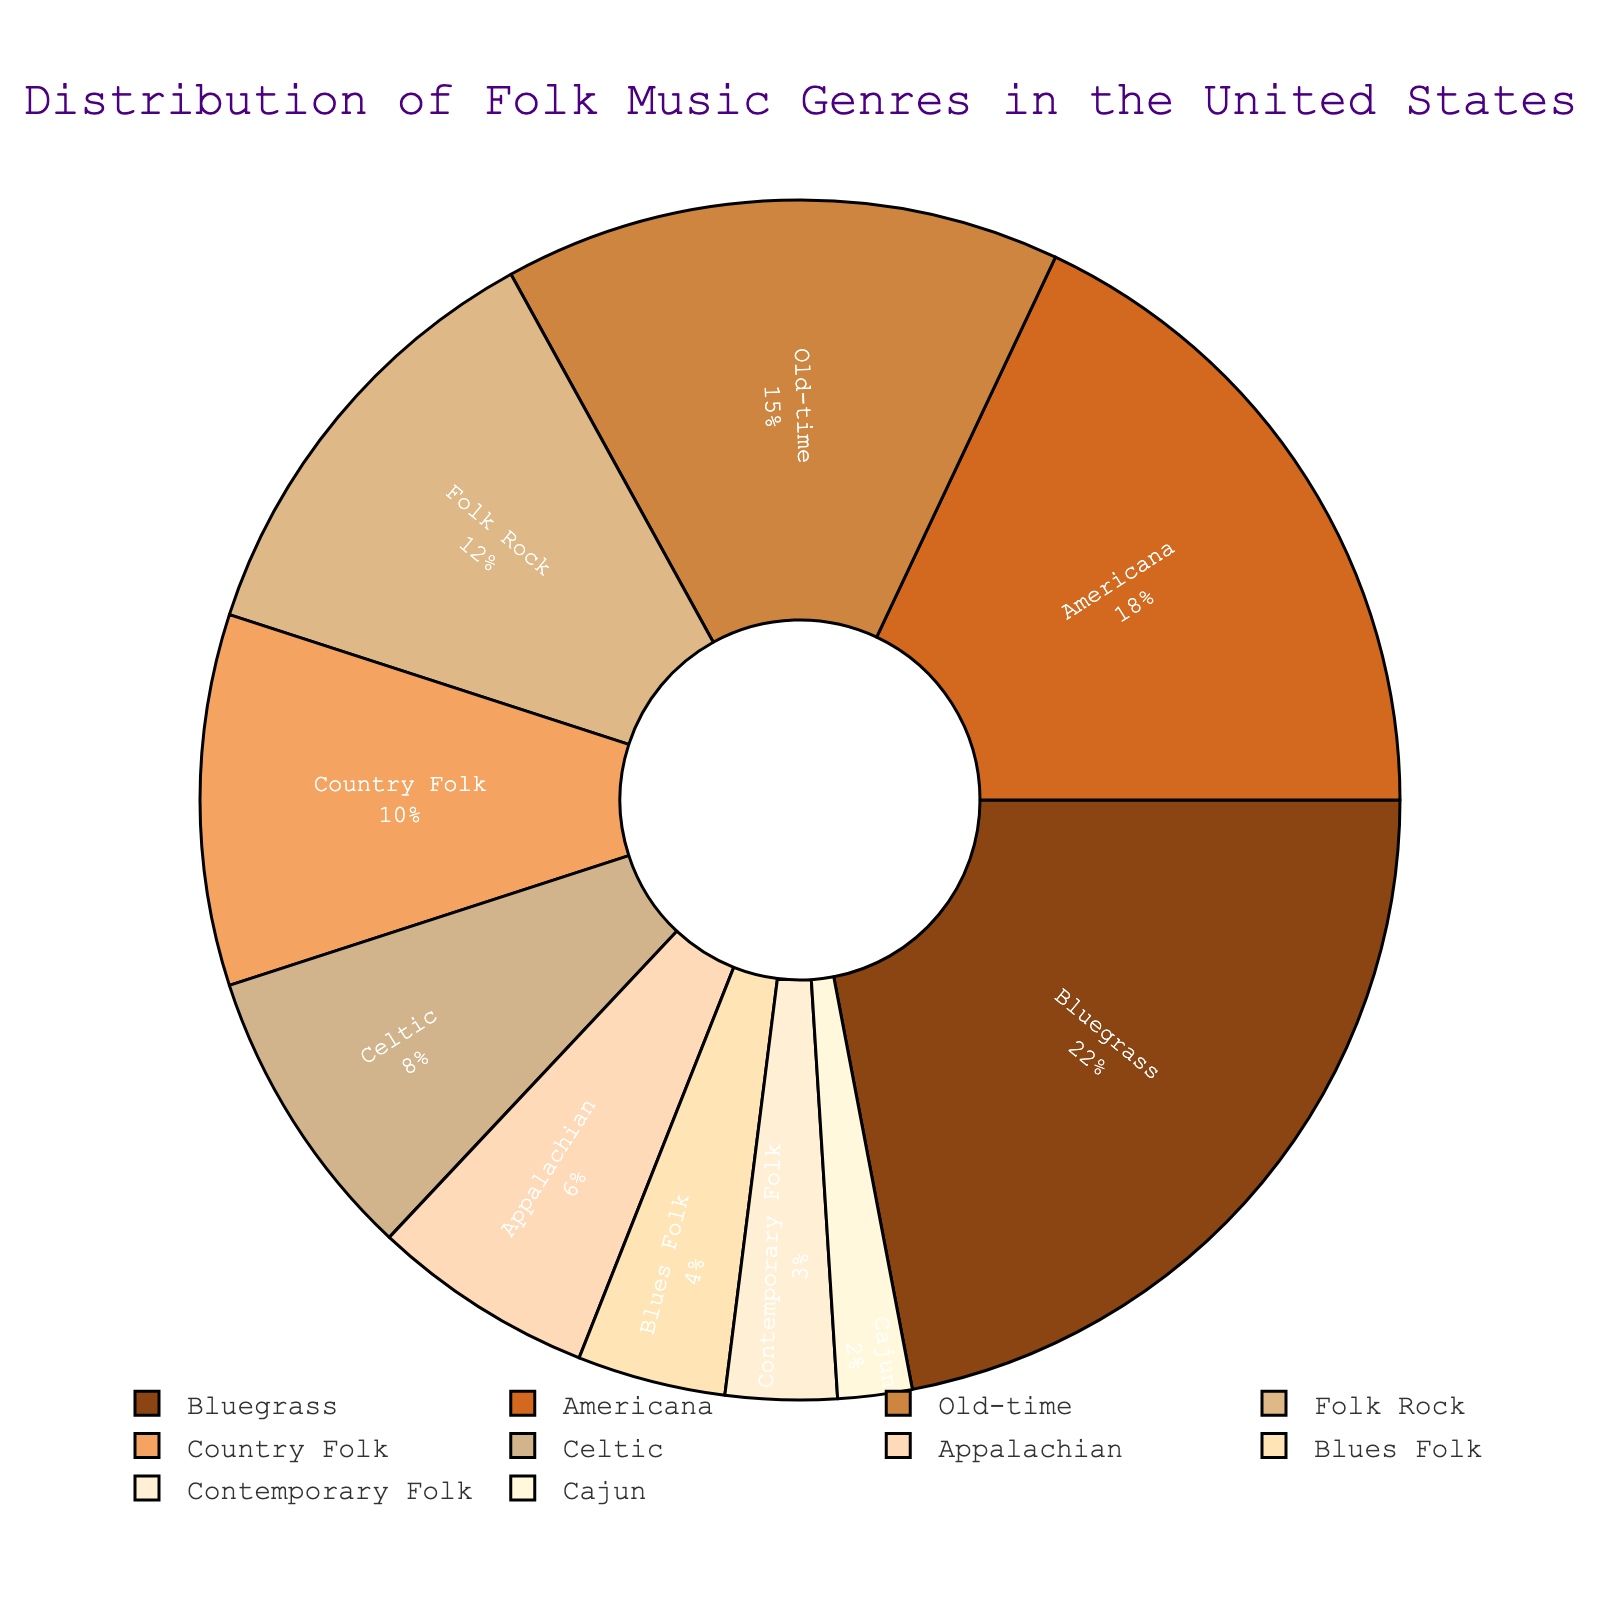What percentage of the pie chart does Bluegrass represent? To find the percentage of the pie chart that Bluegrass represents, simply refer to the Bluegrass section and read its percentage value.
Answer: 22% Which genre is more popular, Americana or Country Folk? Compare the percentages of Americana and Country Folk. Americana has a percentage of 18%, and Country Folk has a percentage of 10%.
Answer: Americana What is the combined percentage of Old-time, Celtic, and Appalachian genres? Add the percentages of Old-time (15%), Celtic (8%), and Appalachian (6%): 15 + 8 + 6 = 29%.
Answer: 29% What genre represents the smallest percentage, and what is its value? Look for the genre with the smallest percentage in the pie chart. Cajun has the smallest percentage, which is 2%.
Answer: Cajun Among Blues Folk and Contemporary Folk, which genre has a smaller percentage? Compare the percentages of Blues Folk (4%) and Contemporary Folk (3%). Contemporary Folk has a smaller percentage.
Answer: Contemporary Folk What is the percentage difference between Bluegrass and Folk Rock? Subtract the percentage of Folk Rock (12%) from the percentage of Bluegrass (22%): 22 - 12 = 10%.
Answer: 10% What is the sum of the percentages for all genres with more than 15% share? Identify the genres with more than 15%: Bluegrass (22%), Americana (18%), and add those percentages: 22 + 18 = 40%.
Answer: 40% What is the average percentage of the genres Celtic, Appalachian, and Blues Folk? Add the percentages of Celtic (8%), Appalachian (6%), and Blues Folk (4%) and divide by 3: (8 + 6 + 4) / 3 = 6%.
Answer: 6% Which genre is the second least popular? Identify the second smallest percentage after Cajun (2%), which is Contemporary Folk at 3%.
Answer: Contemporary Folk If you combine the percentages of genres with less than 10%, what is the total? Add the percentages of genres with less than 10%: Celtic (8%), Appalachian (6%), Blues Folk (4%), Contemporary Folk (3%), Cajun (2%): 8 + 6 + 4 + 3 + 2 = 23%.
Answer: 23% 